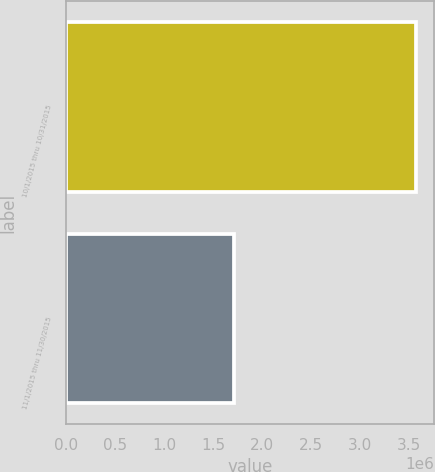<chart> <loc_0><loc_0><loc_500><loc_500><bar_chart><fcel>10/1/2015 thru 10/31/2015<fcel>11/1/2015 thru 11/30/2015<nl><fcel>3.57776e+06<fcel>1.7146e+06<nl></chart> 